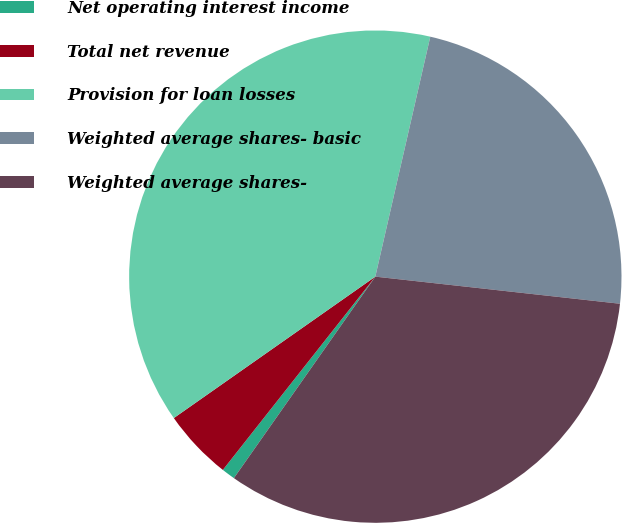Convert chart. <chart><loc_0><loc_0><loc_500><loc_500><pie_chart><fcel>Net operating interest income<fcel>Total net revenue<fcel>Provision for loan losses<fcel>Weighted average shares- basic<fcel>Weighted average shares-<nl><fcel>0.89%<fcel>4.63%<fcel>38.32%<fcel>23.17%<fcel>32.98%<nl></chart> 